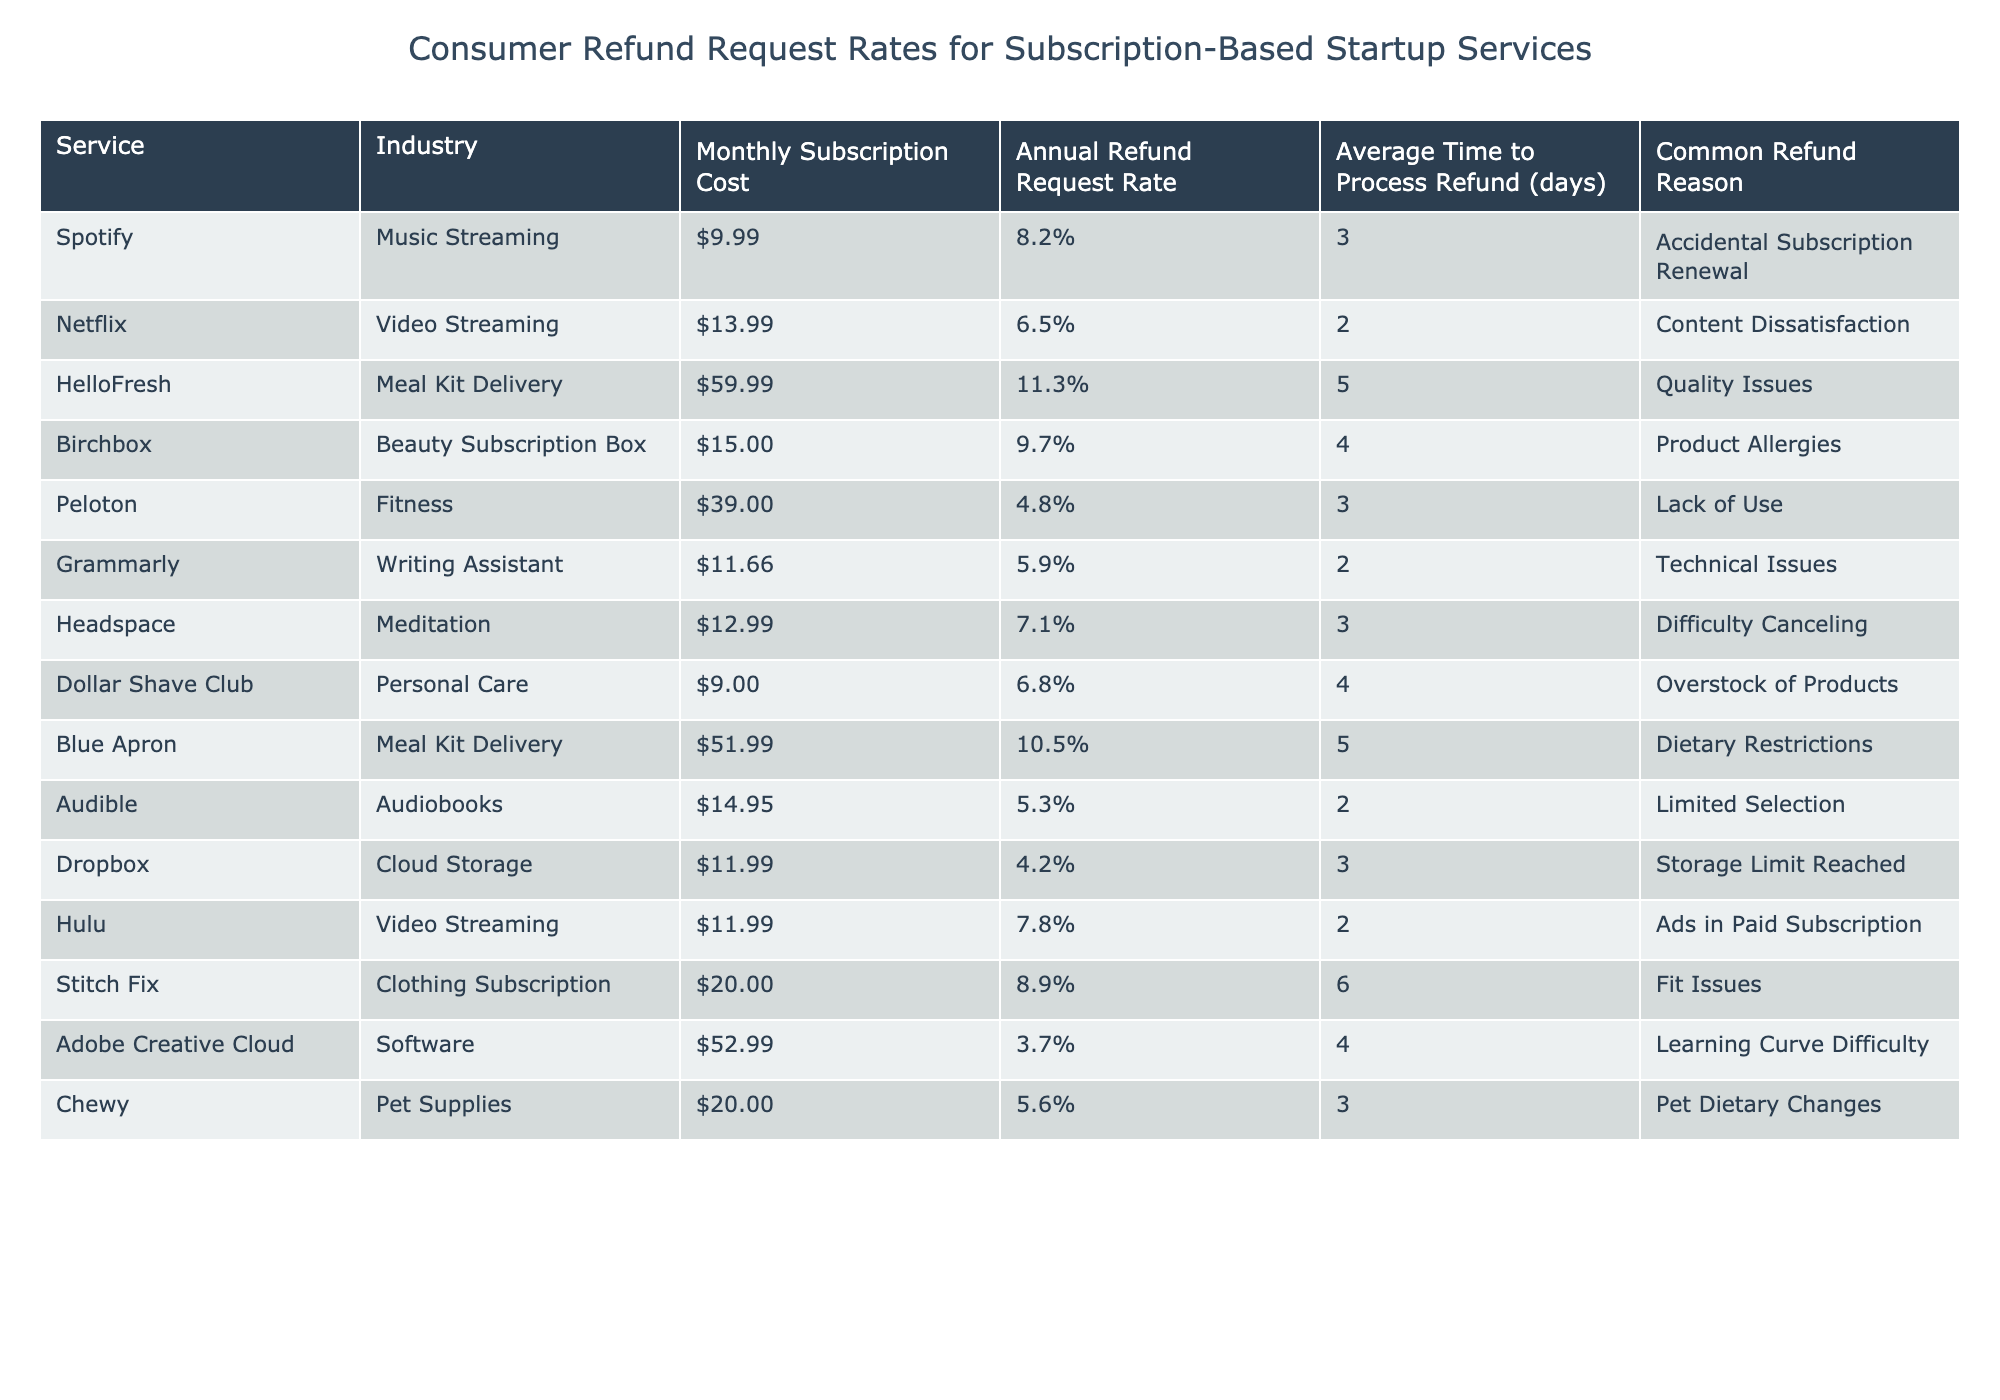What is the monthly subscription cost of the HelloFresh service? The table provides the specific information about the monthly subscription cost for each service. Looking at the row for HelloFresh, the stated cost is $59.99.
Answer: $59.99 Which service has the highest annual refund request rate? To find the highest refund request rate, we can compare the rates for all services listed in the table. HelloFresh has the highest rate at 11.3%.
Answer: 11.3% How long does it take on average to process refunds for Birchbox? The table shows the average time to process refunds for each service. For Birchbox, this average time is given as 4 days.
Answer: 4 days Is the refund request rate for Peloton lower than for Stitch Fix? We can compare the refund rates for Peloton (4.8%) and Stitch Fix (8.9%). Since 4.8% is less than 8.9%, the statement is true.
Answer: Yes Calculate the average refund request rate for the services listed. We need to sum the refund request rates and divide by the number of services. The rates are 8.2%, 6.5%, 11.3%, 9.7%, 4.8%, 5.9%, 7.1%, 6.8%, 10.5%, 5.3%, 4.2%, 7.8%, 8.9%, 3.7%, 5.6%, totaling 7.2%. There are 16 services, so the average is 115.2%/16 = 7.2%.
Answer: 7.2% Which service shows a refund request rate of below 6%? By reviewing the table, we can identify which services have a refund request rate below 6%. The only service that meets this criterion is Dropbox with a rate of 4.2%.
Answer: Dropbox Which service in the meal kit delivery industry has the highest refund request rate? In the meal kit delivery industry, we have two services: HelloFresh (11.3%) and Blue Apron (10.5%). Comparing these, HelloFresh has the higher refund request rate.
Answer: HelloFresh What is the common refund reason for the service with the lowest refund request rate? According to the table, Adobe Creative Cloud has the lowest refund request rate at 3.7%. The common refund reason listed for it is "Learning Curve Difficulty."
Answer: Learning Curve Difficulty Does any video streaming service have an average time to process refunds longer than 3 days? The table shows Hulu (2 days) and Netflix (2 days) as video streaming services, both of which have an average processing time of 3 days or less. Thus, the answer is false for any video streaming service needing more time.
Answer: No Which industry has the highest average refund request rate? To determine the highest average, we analyze the rates across distinct industries: Music Streaming, Video Streaming, Meal Kit Delivery, Beauty Subscription, Fitness, Writing Assistant, Personal Care, and Software. The Meal Kit Delivery industry, led by HelloFresh's 11.3%, has the highest average.
Answer: Meal Kit Delivery Identify the average subscription cost for personal care services. The data shows one service in the personal care industry: Dollar Shave Club at $9.00. Since there is only one service, the average cost is directly this value.
Answer: $9.00 